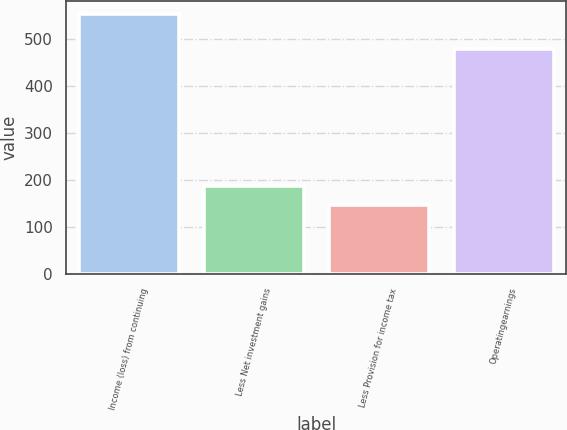Convert chart. <chart><loc_0><loc_0><loc_500><loc_500><bar_chart><fcel>Income (loss) from continuing<fcel>Less Net investment gains<fcel>Less Provision for income tax<fcel>Operatingearnings<nl><fcel>553<fcel>187.6<fcel>147<fcel>479<nl></chart> 